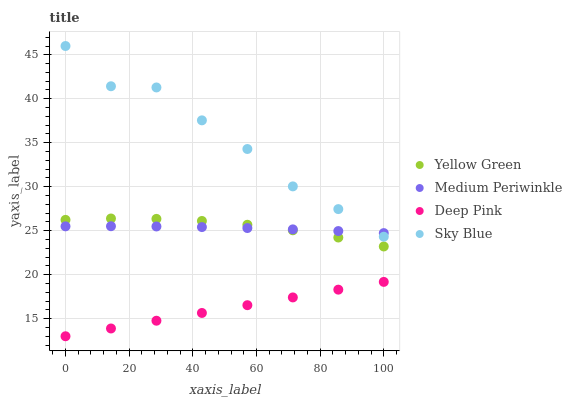Does Deep Pink have the minimum area under the curve?
Answer yes or no. Yes. Does Sky Blue have the maximum area under the curve?
Answer yes or no. Yes. Does Medium Periwinkle have the minimum area under the curve?
Answer yes or no. No. Does Medium Periwinkle have the maximum area under the curve?
Answer yes or no. No. Is Deep Pink the smoothest?
Answer yes or no. Yes. Is Sky Blue the roughest?
Answer yes or no. Yes. Is Medium Periwinkle the smoothest?
Answer yes or no. No. Is Medium Periwinkle the roughest?
Answer yes or no. No. Does Deep Pink have the lowest value?
Answer yes or no. Yes. Does Medium Periwinkle have the lowest value?
Answer yes or no. No. Does Sky Blue have the highest value?
Answer yes or no. Yes. Does Medium Periwinkle have the highest value?
Answer yes or no. No. Is Yellow Green less than Sky Blue?
Answer yes or no. Yes. Is Medium Periwinkle greater than Deep Pink?
Answer yes or no. Yes. Does Sky Blue intersect Medium Periwinkle?
Answer yes or no. Yes. Is Sky Blue less than Medium Periwinkle?
Answer yes or no. No. Is Sky Blue greater than Medium Periwinkle?
Answer yes or no. No. Does Yellow Green intersect Sky Blue?
Answer yes or no. No. 